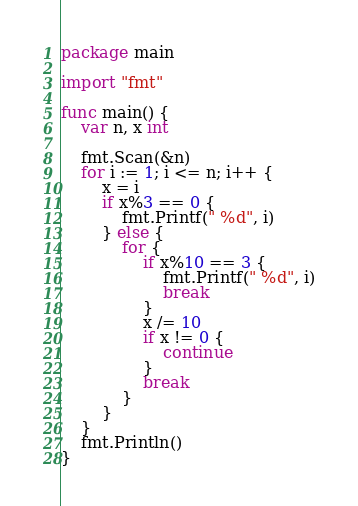<code> <loc_0><loc_0><loc_500><loc_500><_Go_>package main

import "fmt"

func main() {
	var n, x int

	fmt.Scan(&n)
	for i := 1; i <= n; i++ {
		x = i
		if x%3 == 0 {
			fmt.Printf(" %d", i)
		} else {
			for {
				if x%10 == 3 {
					fmt.Printf(" %d", i)
					break
				}
				x /= 10
				if x != 0 {
					continue
				}
				break
			}
		}
	}
	fmt.Println()
}

</code> 